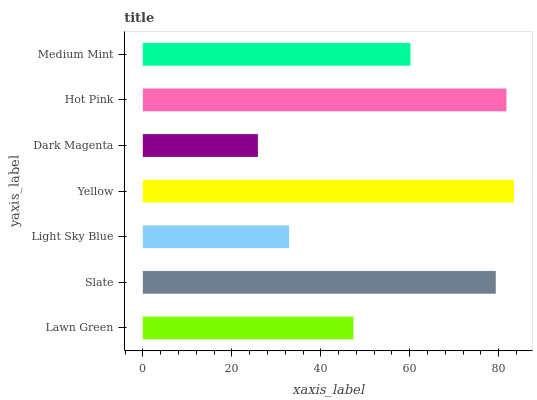Is Dark Magenta the minimum?
Answer yes or no. Yes. Is Yellow the maximum?
Answer yes or no. Yes. Is Slate the minimum?
Answer yes or no. No. Is Slate the maximum?
Answer yes or no. No. Is Slate greater than Lawn Green?
Answer yes or no. Yes. Is Lawn Green less than Slate?
Answer yes or no. Yes. Is Lawn Green greater than Slate?
Answer yes or no. No. Is Slate less than Lawn Green?
Answer yes or no. No. Is Medium Mint the high median?
Answer yes or no. Yes. Is Medium Mint the low median?
Answer yes or no. Yes. Is Yellow the high median?
Answer yes or no. No. Is Lawn Green the low median?
Answer yes or no. No. 